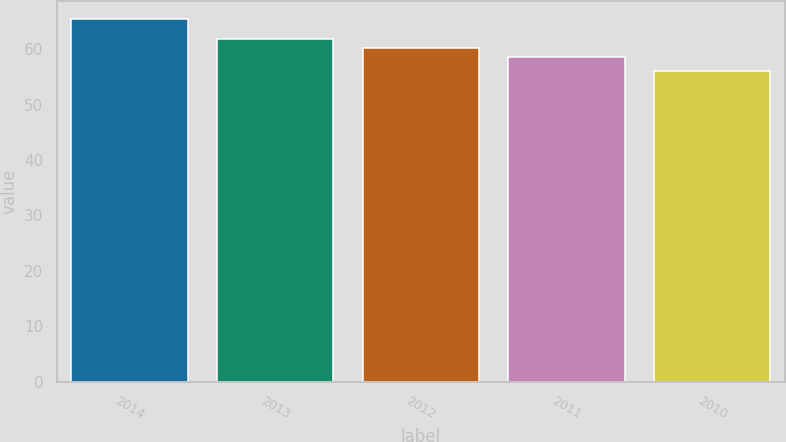<chart> <loc_0><loc_0><loc_500><loc_500><bar_chart><fcel>2014<fcel>2013<fcel>2012<fcel>2011<fcel>2010<nl><fcel>65.37<fcel>61.86<fcel>60.18<fcel>58.68<fcel>56.13<nl></chart> 